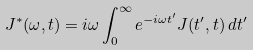<formula> <loc_0><loc_0><loc_500><loc_500>J ^ { * } ( \omega , t ) = i \omega \int _ { 0 } ^ { \infty } e ^ { - i \omega t ^ { \prime } } J ( t ^ { \prime } , t ) \, d t ^ { \prime }</formula> 